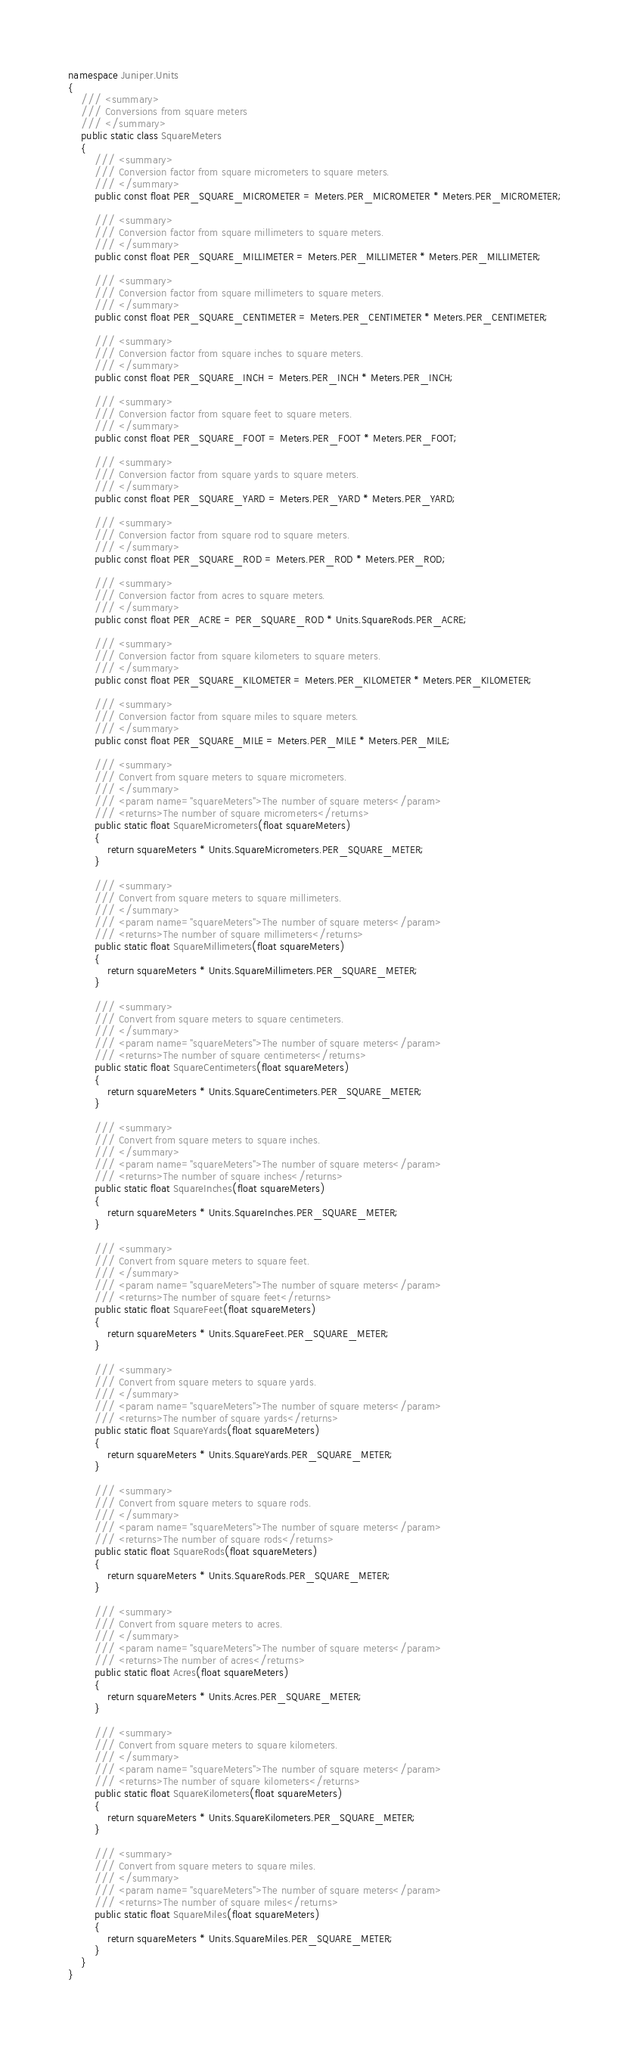<code> <loc_0><loc_0><loc_500><loc_500><_C#_>namespace Juniper.Units
{
    /// <summary>
    /// Conversions from square meters
    /// </summary>
    public static class SquareMeters
    {
        /// <summary>
        /// Conversion factor from square micrometers to square meters.
        /// </summary>
        public const float PER_SQUARE_MICROMETER = Meters.PER_MICROMETER * Meters.PER_MICROMETER;

        /// <summary>
        /// Conversion factor from square millimeters to square meters.
        /// </summary>
        public const float PER_SQUARE_MILLIMETER = Meters.PER_MILLIMETER * Meters.PER_MILLIMETER;

        /// <summary>
        /// Conversion factor from square millimeters to square meters.
        /// </summary>
        public const float PER_SQUARE_CENTIMETER = Meters.PER_CENTIMETER * Meters.PER_CENTIMETER;

        /// <summary>
        /// Conversion factor from square inches to square meters.
        /// </summary>
        public const float PER_SQUARE_INCH = Meters.PER_INCH * Meters.PER_INCH;

        /// <summary>
        /// Conversion factor from square feet to square meters.
        /// </summary>
        public const float PER_SQUARE_FOOT = Meters.PER_FOOT * Meters.PER_FOOT;

        /// <summary>
        /// Conversion factor from square yards to square meters.
        /// </summary>
        public const float PER_SQUARE_YARD = Meters.PER_YARD * Meters.PER_YARD;

        /// <summary>
        /// Conversion factor from square rod to square meters.
        /// </summary>
        public const float PER_SQUARE_ROD = Meters.PER_ROD * Meters.PER_ROD;

        /// <summary>
        /// Conversion factor from acres to square meters.
        /// </summary>
        public const float PER_ACRE = PER_SQUARE_ROD * Units.SquareRods.PER_ACRE;

        /// <summary>
        /// Conversion factor from square kilometers to square meters.
        /// </summary>
        public const float PER_SQUARE_KILOMETER = Meters.PER_KILOMETER * Meters.PER_KILOMETER;

        /// <summary>
        /// Conversion factor from square miles to square meters.
        /// </summary>
        public const float PER_SQUARE_MILE = Meters.PER_MILE * Meters.PER_MILE;

        /// <summary>
        /// Convert from square meters to square micrometers.
        /// </summary>
        /// <param name="squareMeters">The number of square meters</param>
        /// <returns>The number of square micrometers</returns>
        public static float SquareMicrometers(float squareMeters)
        {
            return squareMeters * Units.SquareMicrometers.PER_SQUARE_METER;
        }

        /// <summary>
        /// Convert from square meters to square millimeters.
        /// </summary>
        /// <param name="squareMeters">The number of square meters</param>
        /// <returns>The number of square millimeters</returns>
        public static float SquareMillimeters(float squareMeters)
        {
            return squareMeters * Units.SquareMillimeters.PER_SQUARE_METER;
        }

        /// <summary>
        /// Convert from square meters to square centimeters.
        /// </summary>
        /// <param name="squareMeters">The number of square meters</param>
        /// <returns>The number of square centimeters</returns>
        public static float SquareCentimeters(float squareMeters)
        {
            return squareMeters * Units.SquareCentimeters.PER_SQUARE_METER;
        }

        /// <summary>
        /// Convert from square meters to square inches.
        /// </summary>
        /// <param name="squareMeters">The number of square meters</param>
        /// <returns>The number of square inches</returns>
        public static float SquareInches(float squareMeters)
        {
            return squareMeters * Units.SquareInches.PER_SQUARE_METER;
        }

        /// <summary>
        /// Convert from square meters to square feet.
        /// </summary>
        /// <param name="squareMeters">The number of square meters</param>
        /// <returns>The number of square feet</returns>
        public static float SquareFeet(float squareMeters)
        {
            return squareMeters * Units.SquareFeet.PER_SQUARE_METER;
        }

        /// <summary>
        /// Convert from square meters to square yards.
        /// </summary>
        /// <param name="squareMeters">The number of square meters</param>
        /// <returns>The number of square yards</returns>
        public static float SquareYards(float squareMeters)
        {
            return squareMeters * Units.SquareYards.PER_SQUARE_METER;
        }

        /// <summary>
        /// Convert from square meters to square rods.
        /// </summary>
        /// <param name="squareMeters">The number of square meters</param>
        /// <returns>The number of square rods</returns>
        public static float SquareRods(float squareMeters)
        {
            return squareMeters * Units.SquareRods.PER_SQUARE_METER;
        }

        /// <summary>
        /// Convert from square meters to acres.
        /// </summary>
        /// <param name="squareMeters">The number of square meters</param>
        /// <returns>The number of acres</returns>
        public static float Acres(float squareMeters)
        {
            return squareMeters * Units.Acres.PER_SQUARE_METER;
        }

        /// <summary>
        /// Convert from square meters to square kilometers.
        /// </summary>
        /// <param name="squareMeters">The number of square meters</param>
        /// <returns>The number of square kilometers</returns>
        public static float SquareKilometers(float squareMeters)
        {
            return squareMeters * Units.SquareKilometers.PER_SQUARE_METER;
        }

        /// <summary>
        /// Convert from square meters to square miles.
        /// </summary>
        /// <param name="squareMeters">The number of square meters</param>
        /// <returns>The number of square miles</returns>
        public static float SquareMiles(float squareMeters)
        {
            return squareMeters * Units.SquareMiles.PER_SQUARE_METER;
        }
    }
}</code> 